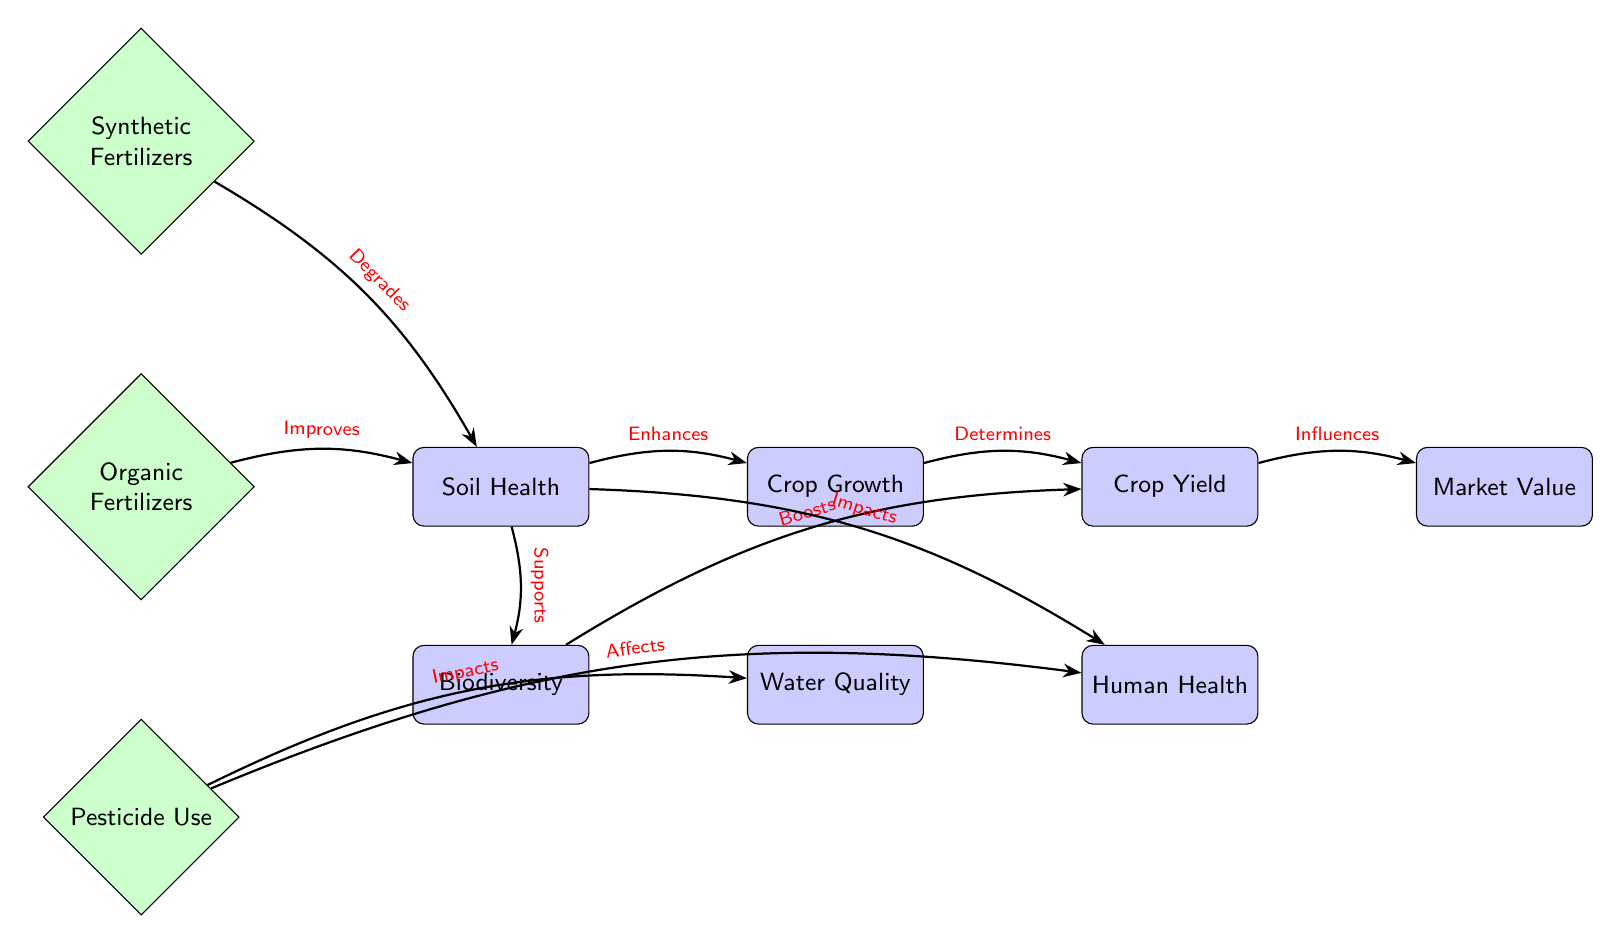What nodes are in the diagram? The diagram contains the following nodes: Soil Health, Crop Growth, Water Quality, Organic Fertilizers, Synthetic Fertilizers, Pesticide Use, Biodiversity, Crop Yield, Human Health, and Market Value.
Answer: Soil Health, Crop Growth, Water Quality, Organic Fertilizers, Synthetic Fertilizers, Pesticide Use, Biodiversity, Crop Yield, Human Health, Market Value How many edges are in the diagram? The diagram has a total of 9 edges connecting the nodes. Each edge represents a relationship between the nodes.
Answer: 9 What impact do organic fertilizers have on soil health? According to the diagram, organic fertilizers "Improves" soil health, indicating a positive effect on it.
Answer: Improves What effect does pesticide use have on water quality? The diagram states that pesticide use "Impacts" water quality, suggesting that it can be detrimental to water resources.
Answer: Impacts Which farming practice affects human health according to the diagram? The diagram indicates that pesticide use "Affects" human health, highlighting a potential risk associated with it.
Answer: Pesticide Use What influences market value of crops? The diagram shows that crop yield "Influences" market value, suggesting that greater crop yield can lead to higher market value.
Answer: Crop Yield How does soil health relate to crop growth? The diagram indicates that soil health "Enhances" crop growth, meaning better soil health leads to improved growth of crops.
Answer: Enhances What does biodiversity boost in this food chain? In the diagram, biodiversity "Boosts" crop yield, indicating that a thriving biodiversity positively affects the amount of crops produced.
Answer: Crop Yield What is the effect of synthetic fertilizers on soil health? The diagram states that synthetic fertilizers "Degrades" soil health, suggesting a negative impact on its quality.
Answer: Degrades 